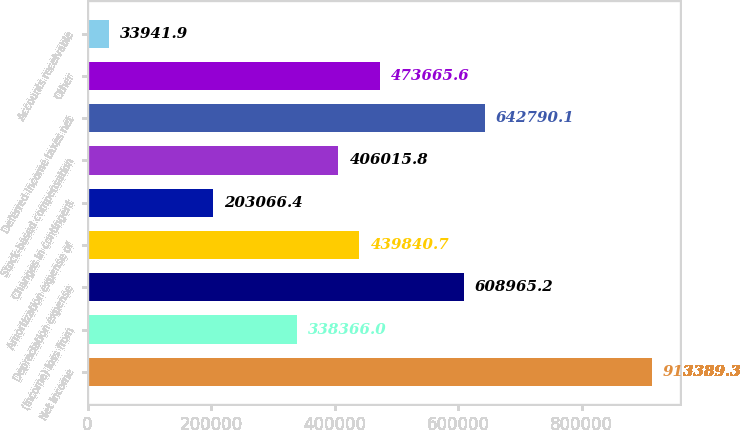Convert chart to OTSL. <chart><loc_0><loc_0><loc_500><loc_500><bar_chart><fcel>Net income<fcel>(Income) loss from<fcel>Depreciation expense<fcel>Amortization expense of<fcel>Changes in contingent<fcel>Stock-based compensation<fcel>Deferred income taxes net<fcel>Other<fcel>Accounts receivable<nl><fcel>913389<fcel>338366<fcel>608965<fcel>439841<fcel>203066<fcel>406016<fcel>642790<fcel>473666<fcel>33941.9<nl></chart> 